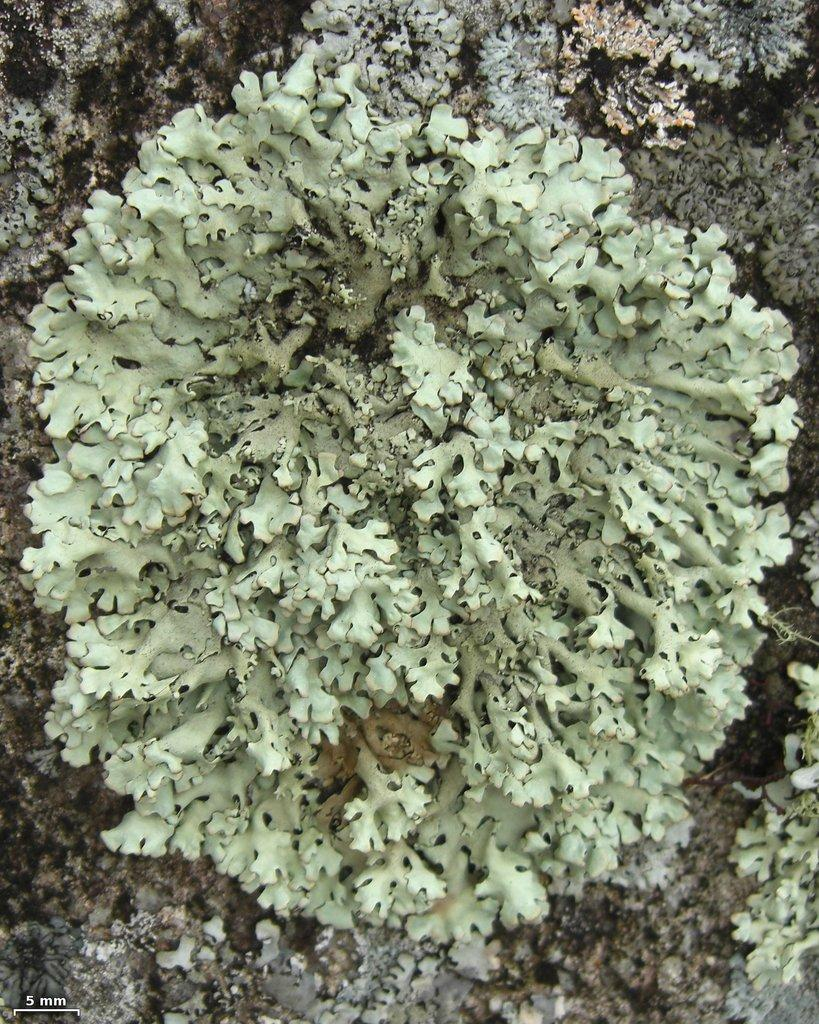What type of organism can be seen in the image? There is fungus in the image. What type of plate is used to serve the fungus in the image? There is no plate present in the image, as it only features fungus. 